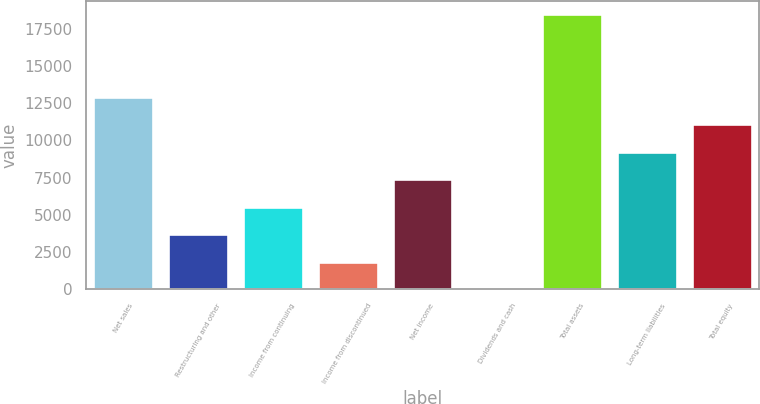<chart> <loc_0><loc_0><loc_500><loc_500><bar_chart><fcel>Net sales<fcel>Restructuring and other<fcel>Income from continuing<fcel>Income from discontinued<fcel>Net income<fcel>Dividends and cash<fcel>Total assets<fcel>Long-term liabilities<fcel>Total equity<nl><fcel>12923<fcel>3692.94<fcel>5538.95<fcel>1846.93<fcel>7384.96<fcel>0.92<fcel>18461<fcel>9230.97<fcel>11077<nl></chart> 